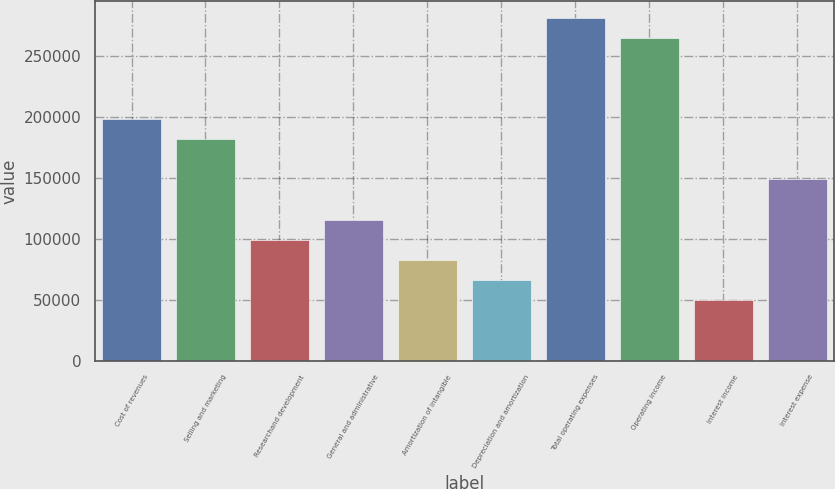Convert chart. <chart><loc_0><loc_0><loc_500><loc_500><bar_chart><fcel>Cost of revenues<fcel>Selling and marketing<fcel>Researchand development<fcel>General and administrative<fcel>Amortization of intangible<fcel>Depreciation and amortization<fcel>Total operating expenses<fcel>Operating income<fcel>Interest income<fcel>Interest expense<nl><fcel>198207<fcel>181690<fcel>99104.1<fcel>115621<fcel>82586.8<fcel>66069.6<fcel>280794<fcel>264276<fcel>49552.4<fcel>148656<nl></chart> 